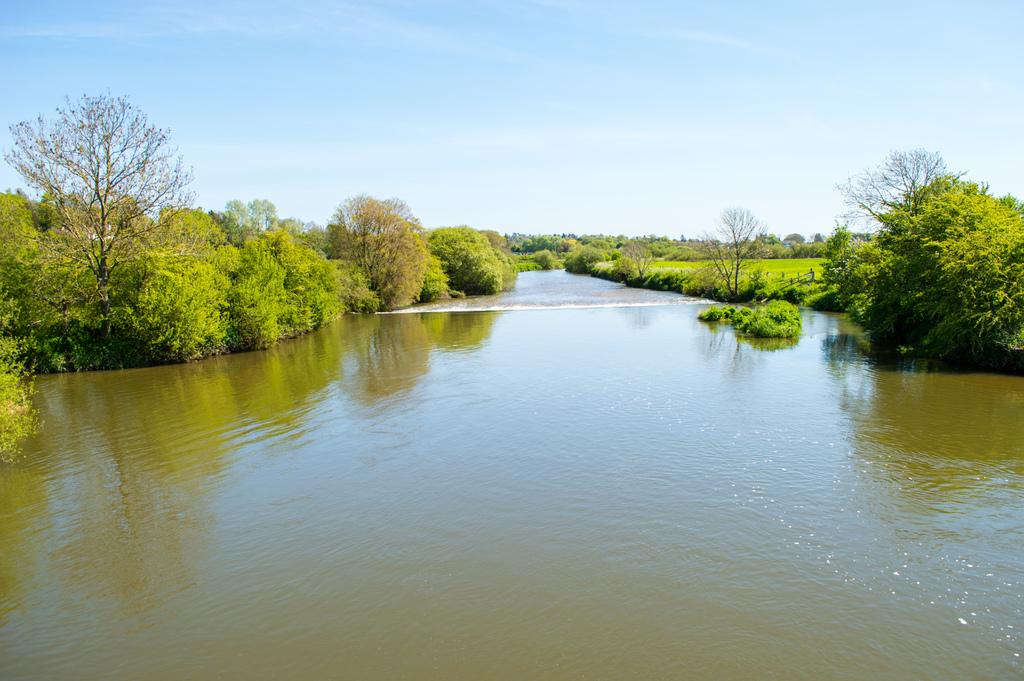What type of location is depicted in the image? The image is an outside view. What natural feature can be seen at the bottom of the image? There is a sea at the bottom of the image. What type of vegetation is visible in the background of the image? There are many trees in the background of the image. What is visible at the top of the image? The sky is visible at the top of the image. What type of cup can be seen in the hands of the creature in the image? There is no creature or cup present in the image. How many apples are hanging from the trees in the image? The image does not specify the type of trees or the presence of apples; it only mentions that there are many trees in the background. 